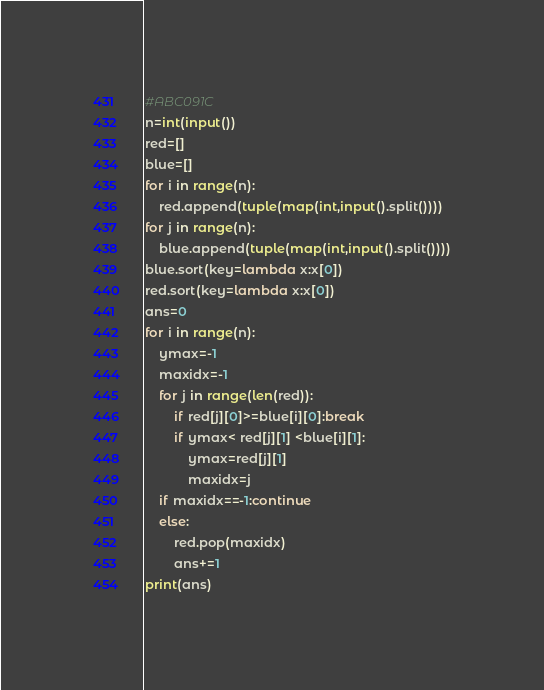Convert code to text. <code><loc_0><loc_0><loc_500><loc_500><_Python_>#ABC091C
n=int(input())
red=[]
blue=[]
for i in range(n):
    red.append(tuple(map(int,input().split())))
for j in range(n):
    blue.append(tuple(map(int,input().split())))
blue.sort(key=lambda x:x[0])
red.sort(key=lambda x:x[0])
ans=0
for i in range(n):
    ymax=-1
    maxidx=-1
    for j in range(len(red)):
        if red[j][0]>=blue[i][0]:break
        if ymax< red[j][1] <blue[i][1]:
            ymax=red[j][1]
            maxidx=j
    if maxidx==-1:continue
    else:
        red.pop(maxidx)
        ans+=1
print(ans)</code> 